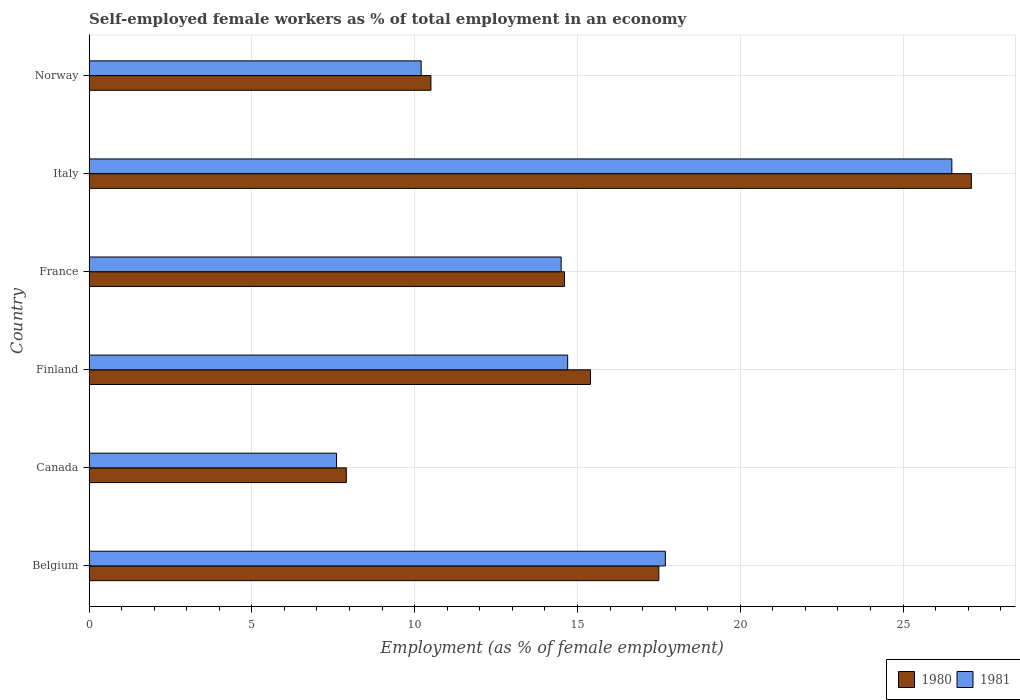How many different coloured bars are there?
Make the answer very short. 2. Are the number of bars on each tick of the Y-axis equal?
Make the answer very short. Yes. How many bars are there on the 6th tick from the top?
Provide a short and direct response. 2. What is the label of the 6th group of bars from the top?
Your answer should be compact. Belgium. In how many cases, is the number of bars for a given country not equal to the number of legend labels?
Make the answer very short. 0. What is the percentage of self-employed female workers in 1980 in Italy?
Your answer should be compact. 27.1. Across all countries, what is the maximum percentage of self-employed female workers in 1981?
Provide a succinct answer. 26.5. Across all countries, what is the minimum percentage of self-employed female workers in 1981?
Give a very brief answer. 7.6. In which country was the percentage of self-employed female workers in 1981 maximum?
Ensure brevity in your answer.  Italy. In which country was the percentage of self-employed female workers in 1980 minimum?
Make the answer very short. Canada. What is the total percentage of self-employed female workers in 1981 in the graph?
Ensure brevity in your answer.  91.2. What is the difference between the percentage of self-employed female workers in 1981 in Finland and that in Norway?
Offer a very short reply. 4.5. What is the difference between the percentage of self-employed female workers in 1981 in Italy and the percentage of self-employed female workers in 1980 in Canada?
Keep it short and to the point. 18.6. What is the average percentage of self-employed female workers in 1981 per country?
Offer a terse response. 15.2. What is the difference between the percentage of self-employed female workers in 1981 and percentage of self-employed female workers in 1980 in Belgium?
Provide a short and direct response. 0.2. What is the ratio of the percentage of self-employed female workers in 1980 in Finland to that in France?
Your answer should be compact. 1.05. Is the percentage of self-employed female workers in 1980 in Finland less than that in Norway?
Offer a terse response. No. What is the difference between the highest and the second highest percentage of self-employed female workers in 1980?
Make the answer very short. 9.6. What is the difference between the highest and the lowest percentage of self-employed female workers in 1981?
Your answer should be compact. 18.9. In how many countries, is the percentage of self-employed female workers in 1980 greater than the average percentage of self-employed female workers in 1980 taken over all countries?
Offer a very short reply. 2. Are all the bars in the graph horizontal?
Keep it short and to the point. Yes. Are the values on the major ticks of X-axis written in scientific E-notation?
Provide a short and direct response. No. Where does the legend appear in the graph?
Give a very brief answer. Bottom right. How many legend labels are there?
Keep it short and to the point. 2. What is the title of the graph?
Make the answer very short. Self-employed female workers as % of total employment in an economy. What is the label or title of the X-axis?
Your answer should be very brief. Employment (as % of female employment). What is the label or title of the Y-axis?
Offer a terse response. Country. What is the Employment (as % of female employment) of 1981 in Belgium?
Offer a very short reply. 17.7. What is the Employment (as % of female employment) in 1980 in Canada?
Provide a short and direct response. 7.9. What is the Employment (as % of female employment) of 1981 in Canada?
Make the answer very short. 7.6. What is the Employment (as % of female employment) of 1980 in Finland?
Your answer should be very brief. 15.4. What is the Employment (as % of female employment) of 1981 in Finland?
Offer a terse response. 14.7. What is the Employment (as % of female employment) of 1980 in France?
Provide a short and direct response. 14.6. What is the Employment (as % of female employment) of 1981 in France?
Your response must be concise. 14.5. What is the Employment (as % of female employment) in 1980 in Italy?
Keep it short and to the point. 27.1. What is the Employment (as % of female employment) of 1981 in Italy?
Your response must be concise. 26.5. What is the Employment (as % of female employment) of 1980 in Norway?
Offer a very short reply. 10.5. What is the Employment (as % of female employment) in 1981 in Norway?
Keep it short and to the point. 10.2. Across all countries, what is the maximum Employment (as % of female employment) of 1980?
Your answer should be compact. 27.1. Across all countries, what is the maximum Employment (as % of female employment) in 1981?
Offer a terse response. 26.5. Across all countries, what is the minimum Employment (as % of female employment) of 1980?
Your answer should be compact. 7.9. Across all countries, what is the minimum Employment (as % of female employment) of 1981?
Your answer should be very brief. 7.6. What is the total Employment (as % of female employment) in 1980 in the graph?
Keep it short and to the point. 93. What is the total Employment (as % of female employment) of 1981 in the graph?
Your answer should be compact. 91.2. What is the difference between the Employment (as % of female employment) of 1981 in Belgium and that in Finland?
Make the answer very short. 3. What is the difference between the Employment (as % of female employment) of 1980 in Belgium and that in France?
Offer a terse response. 2.9. What is the difference between the Employment (as % of female employment) of 1981 in Belgium and that in France?
Ensure brevity in your answer.  3.2. What is the difference between the Employment (as % of female employment) in 1980 in Canada and that in Finland?
Provide a short and direct response. -7.5. What is the difference between the Employment (as % of female employment) of 1980 in Canada and that in France?
Your answer should be compact. -6.7. What is the difference between the Employment (as % of female employment) of 1981 in Canada and that in France?
Offer a very short reply. -6.9. What is the difference between the Employment (as % of female employment) in 1980 in Canada and that in Italy?
Give a very brief answer. -19.2. What is the difference between the Employment (as % of female employment) in 1981 in Canada and that in Italy?
Your answer should be very brief. -18.9. What is the difference between the Employment (as % of female employment) in 1980 in Canada and that in Norway?
Offer a terse response. -2.6. What is the difference between the Employment (as % of female employment) of 1981 in Canada and that in Norway?
Your answer should be compact. -2.6. What is the difference between the Employment (as % of female employment) of 1980 in Finland and that in France?
Give a very brief answer. 0.8. What is the difference between the Employment (as % of female employment) of 1981 in Finland and that in Norway?
Give a very brief answer. 4.5. What is the difference between the Employment (as % of female employment) of 1980 in France and that in Italy?
Make the answer very short. -12.5. What is the difference between the Employment (as % of female employment) in 1981 in France and that in Italy?
Give a very brief answer. -12. What is the difference between the Employment (as % of female employment) in 1980 in France and that in Norway?
Make the answer very short. 4.1. What is the difference between the Employment (as % of female employment) in 1981 in France and that in Norway?
Provide a succinct answer. 4.3. What is the difference between the Employment (as % of female employment) in 1980 in Belgium and the Employment (as % of female employment) in 1981 in Canada?
Ensure brevity in your answer.  9.9. What is the difference between the Employment (as % of female employment) of 1980 in Belgium and the Employment (as % of female employment) of 1981 in Italy?
Offer a terse response. -9. What is the difference between the Employment (as % of female employment) in 1980 in Belgium and the Employment (as % of female employment) in 1981 in Norway?
Provide a succinct answer. 7.3. What is the difference between the Employment (as % of female employment) of 1980 in Canada and the Employment (as % of female employment) of 1981 in Finland?
Offer a very short reply. -6.8. What is the difference between the Employment (as % of female employment) of 1980 in Canada and the Employment (as % of female employment) of 1981 in France?
Offer a terse response. -6.6. What is the difference between the Employment (as % of female employment) in 1980 in Canada and the Employment (as % of female employment) in 1981 in Italy?
Make the answer very short. -18.6. What is the difference between the Employment (as % of female employment) in 1980 in France and the Employment (as % of female employment) in 1981 in Norway?
Your answer should be very brief. 4.4. What is the average Employment (as % of female employment) of 1980 per country?
Offer a very short reply. 15.5. What is the difference between the Employment (as % of female employment) of 1980 and Employment (as % of female employment) of 1981 in Finland?
Provide a short and direct response. 0.7. What is the ratio of the Employment (as % of female employment) of 1980 in Belgium to that in Canada?
Ensure brevity in your answer.  2.22. What is the ratio of the Employment (as % of female employment) of 1981 in Belgium to that in Canada?
Offer a very short reply. 2.33. What is the ratio of the Employment (as % of female employment) in 1980 in Belgium to that in Finland?
Your answer should be compact. 1.14. What is the ratio of the Employment (as % of female employment) of 1981 in Belgium to that in Finland?
Make the answer very short. 1.2. What is the ratio of the Employment (as % of female employment) of 1980 in Belgium to that in France?
Your response must be concise. 1.2. What is the ratio of the Employment (as % of female employment) of 1981 in Belgium to that in France?
Offer a very short reply. 1.22. What is the ratio of the Employment (as % of female employment) of 1980 in Belgium to that in Italy?
Offer a very short reply. 0.65. What is the ratio of the Employment (as % of female employment) of 1981 in Belgium to that in Italy?
Offer a terse response. 0.67. What is the ratio of the Employment (as % of female employment) of 1980 in Belgium to that in Norway?
Provide a short and direct response. 1.67. What is the ratio of the Employment (as % of female employment) in 1981 in Belgium to that in Norway?
Your response must be concise. 1.74. What is the ratio of the Employment (as % of female employment) in 1980 in Canada to that in Finland?
Offer a very short reply. 0.51. What is the ratio of the Employment (as % of female employment) in 1981 in Canada to that in Finland?
Your response must be concise. 0.52. What is the ratio of the Employment (as % of female employment) in 1980 in Canada to that in France?
Provide a short and direct response. 0.54. What is the ratio of the Employment (as % of female employment) in 1981 in Canada to that in France?
Your answer should be very brief. 0.52. What is the ratio of the Employment (as % of female employment) of 1980 in Canada to that in Italy?
Offer a terse response. 0.29. What is the ratio of the Employment (as % of female employment) in 1981 in Canada to that in Italy?
Make the answer very short. 0.29. What is the ratio of the Employment (as % of female employment) in 1980 in Canada to that in Norway?
Offer a terse response. 0.75. What is the ratio of the Employment (as % of female employment) in 1981 in Canada to that in Norway?
Offer a terse response. 0.75. What is the ratio of the Employment (as % of female employment) in 1980 in Finland to that in France?
Keep it short and to the point. 1.05. What is the ratio of the Employment (as % of female employment) of 1981 in Finland to that in France?
Keep it short and to the point. 1.01. What is the ratio of the Employment (as % of female employment) in 1980 in Finland to that in Italy?
Give a very brief answer. 0.57. What is the ratio of the Employment (as % of female employment) in 1981 in Finland to that in Italy?
Give a very brief answer. 0.55. What is the ratio of the Employment (as % of female employment) of 1980 in Finland to that in Norway?
Make the answer very short. 1.47. What is the ratio of the Employment (as % of female employment) of 1981 in Finland to that in Norway?
Give a very brief answer. 1.44. What is the ratio of the Employment (as % of female employment) in 1980 in France to that in Italy?
Your answer should be very brief. 0.54. What is the ratio of the Employment (as % of female employment) in 1981 in France to that in Italy?
Your answer should be very brief. 0.55. What is the ratio of the Employment (as % of female employment) of 1980 in France to that in Norway?
Offer a very short reply. 1.39. What is the ratio of the Employment (as % of female employment) in 1981 in France to that in Norway?
Your response must be concise. 1.42. What is the ratio of the Employment (as % of female employment) of 1980 in Italy to that in Norway?
Make the answer very short. 2.58. What is the ratio of the Employment (as % of female employment) of 1981 in Italy to that in Norway?
Provide a succinct answer. 2.6. What is the difference between the highest and the second highest Employment (as % of female employment) in 1981?
Offer a terse response. 8.8. What is the difference between the highest and the lowest Employment (as % of female employment) of 1981?
Your answer should be compact. 18.9. 